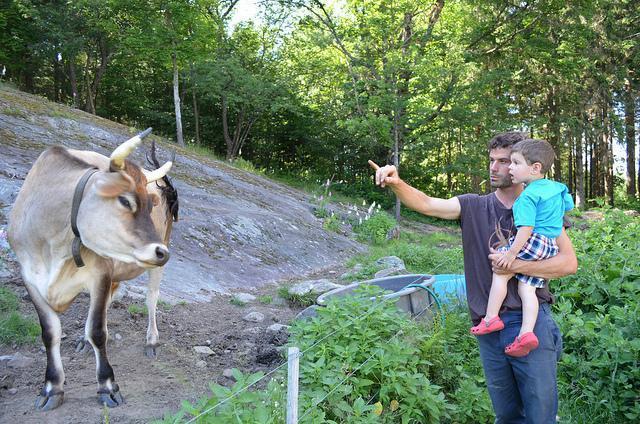How many people are in the picture?
Give a very brief answer. 2. How many skateboards are visible in the image?
Give a very brief answer. 0. 